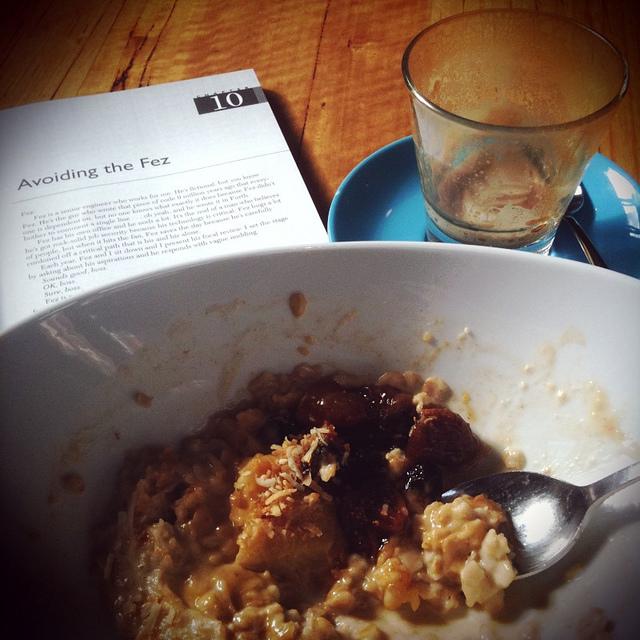What utensil is being used?
Short answer required. Spoon. What does the book say?
Be succinct. Avoiding the fez. What are they eating?
Give a very brief answer. Oatmeal. 